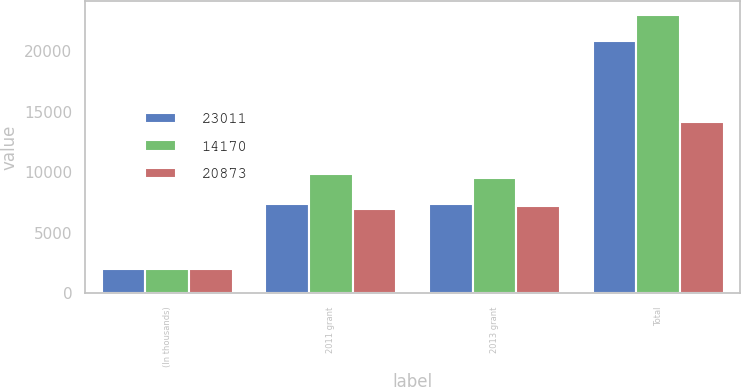Convert chart. <chart><loc_0><loc_0><loc_500><loc_500><stacked_bar_chart><ecel><fcel>(In thousands)<fcel>2011 grant<fcel>2013 grant<fcel>Total<nl><fcel>23011<fcel>2015<fcel>7397<fcel>7336<fcel>20873<nl><fcel>14170<fcel>2014<fcel>9855<fcel>9493<fcel>23011<nl><fcel>20873<fcel>2013<fcel>6939<fcel>7231<fcel>14170<nl></chart> 